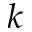<formula> <loc_0><loc_0><loc_500><loc_500>k</formula> 